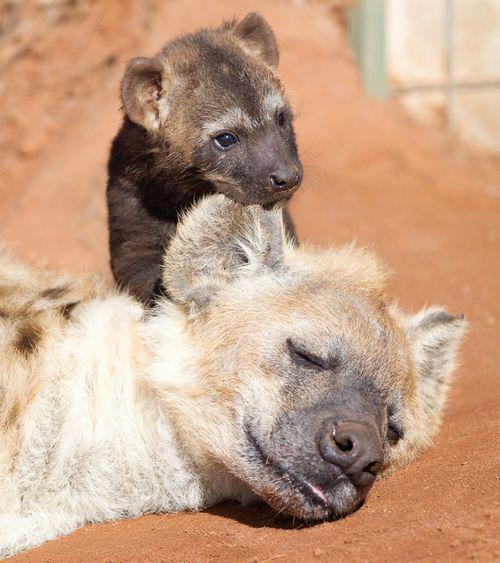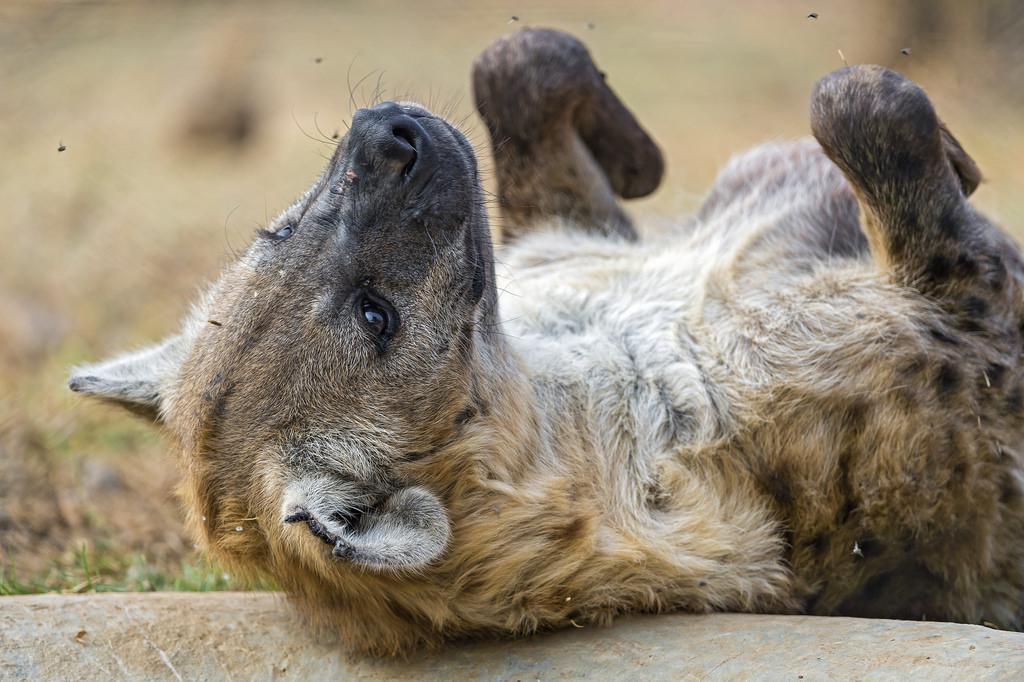The first image is the image on the left, the second image is the image on the right. Evaluate the accuracy of this statement regarding the images: "An image shows a dark baby hyena posed with its head over the ear of a reclining adult hyena.". Is it true? Answer yes or no. Yes. The first image is the image on the left, the second image is the image on the right. For the images displayed, is the sentence "The left image contains two hyenas." factually correct? Answer yes or no. Yes. 